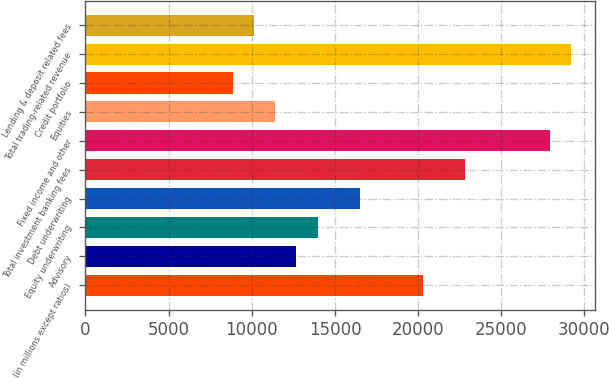Convert chart. <chart><loc_0><loc_0><loc_500><loc_500><bar_chart><fcel>(in millions except ratios)<fcel>Advisory<fcel>Equity underwriting<fcel>Debt underwriting<fcel>Total investment banking fees<fcel>Fixed income and other<fcel>Equities<fcel>Credit portfolio<fcel>Total trading-related revenue<fcel>Lending & deposit related fees<nl><fcel>20294.1<fcel>12684<fcel>13952.4<fcel>16489.1<fcel>22830.8<fcel>27904.1<fcel>11415.7<fcel>8879.02<fcel>29172.5<fcel>10147.4<nl></chart> 